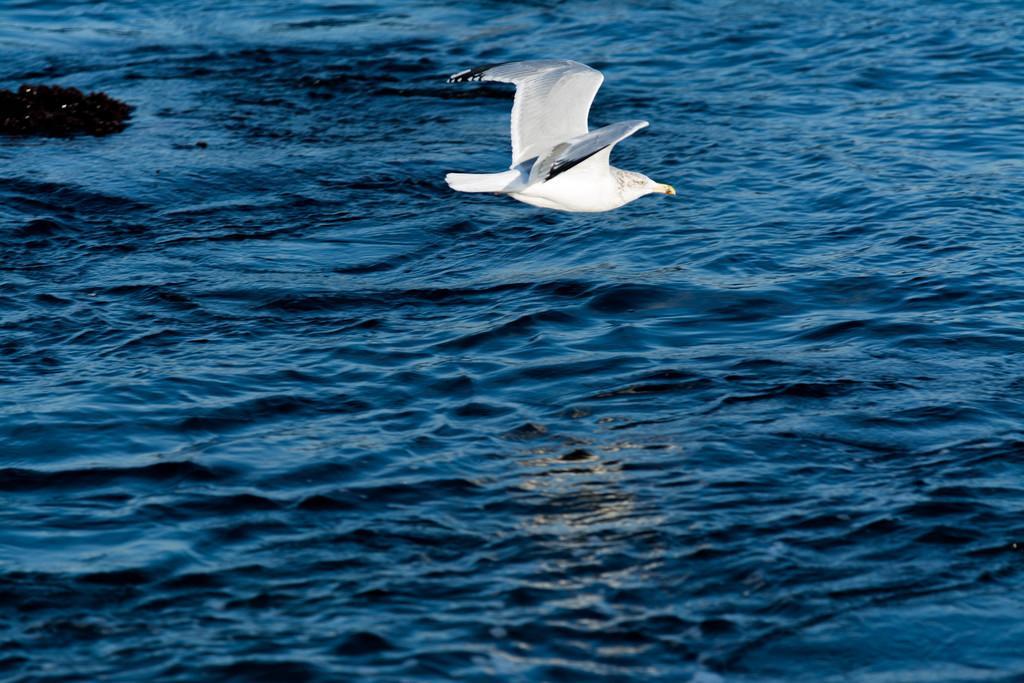Could you give a brief overview of what you see in this image? In the center of the image there is a white color bird. At the bottom of the image there is water. 